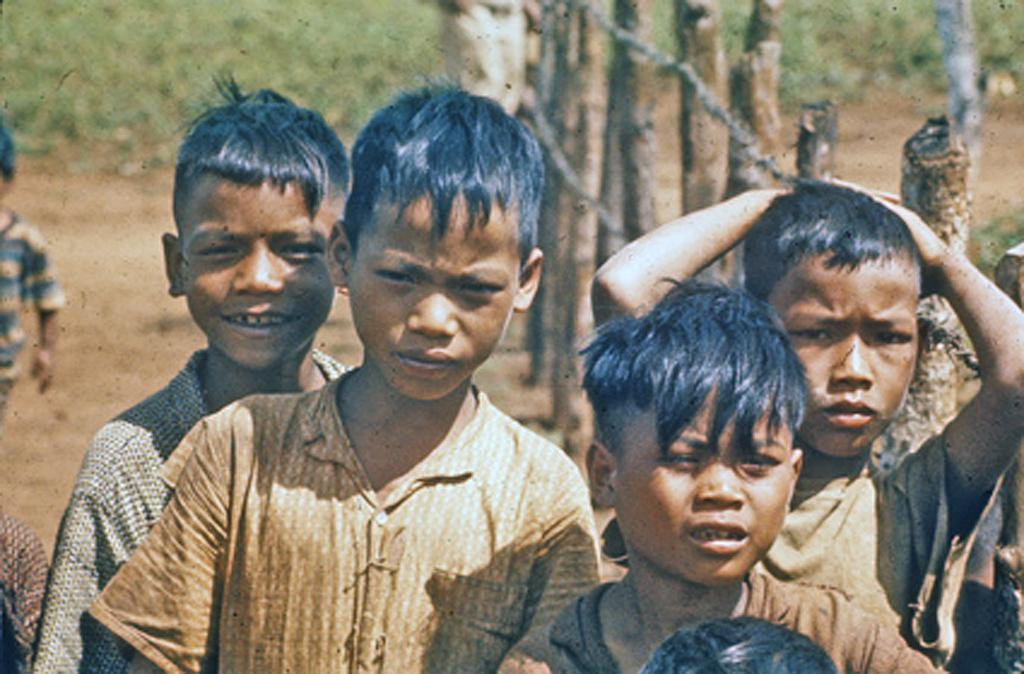Who is present in the image? There are kids in the image. Where are the kids located in relation to the fencing? The kids are beside the fencing. Can you describe the background of the image? The background of the image is blurred. What type of volcano can be seen erupting in the background of the image? There is no volcano present in the image; the background is blurred. Can you describe the color and texture of the sofa in the image? There is no sofa present in the image; it features kids beside the fencing. 